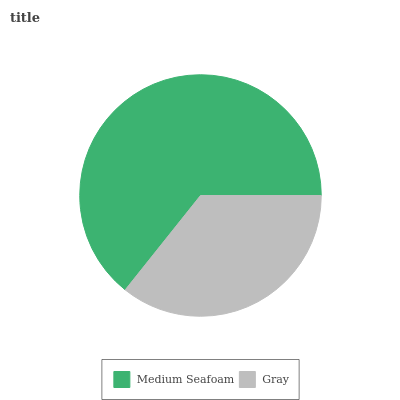Is Gray the minimum?
Answer yes or no. Yes. Is Medium Seafoam the maximum?
Answer yes or no. Yes. Is Gray the maximum?
Answer yes or no. No. Is Medium Seafoam greater than Gray?
Answer yes or no. Yes. Is Gray less than Medium Seafoam?
Answer yes or no. Yes. Is Gray greater than Medium Seafoam?
Answer yes or no. No. Is Medium Seafoam less than Gray?
Answer yes or no. No. Is Medium Seafoam the high median?
Answer yes or no. Yes. Is Gray the low median?
Answer yes or no. Yes. Is Gray the high median?
Answer yes or no. No. Is Medium Seafoam the low median?
Answer yes or no. No. 